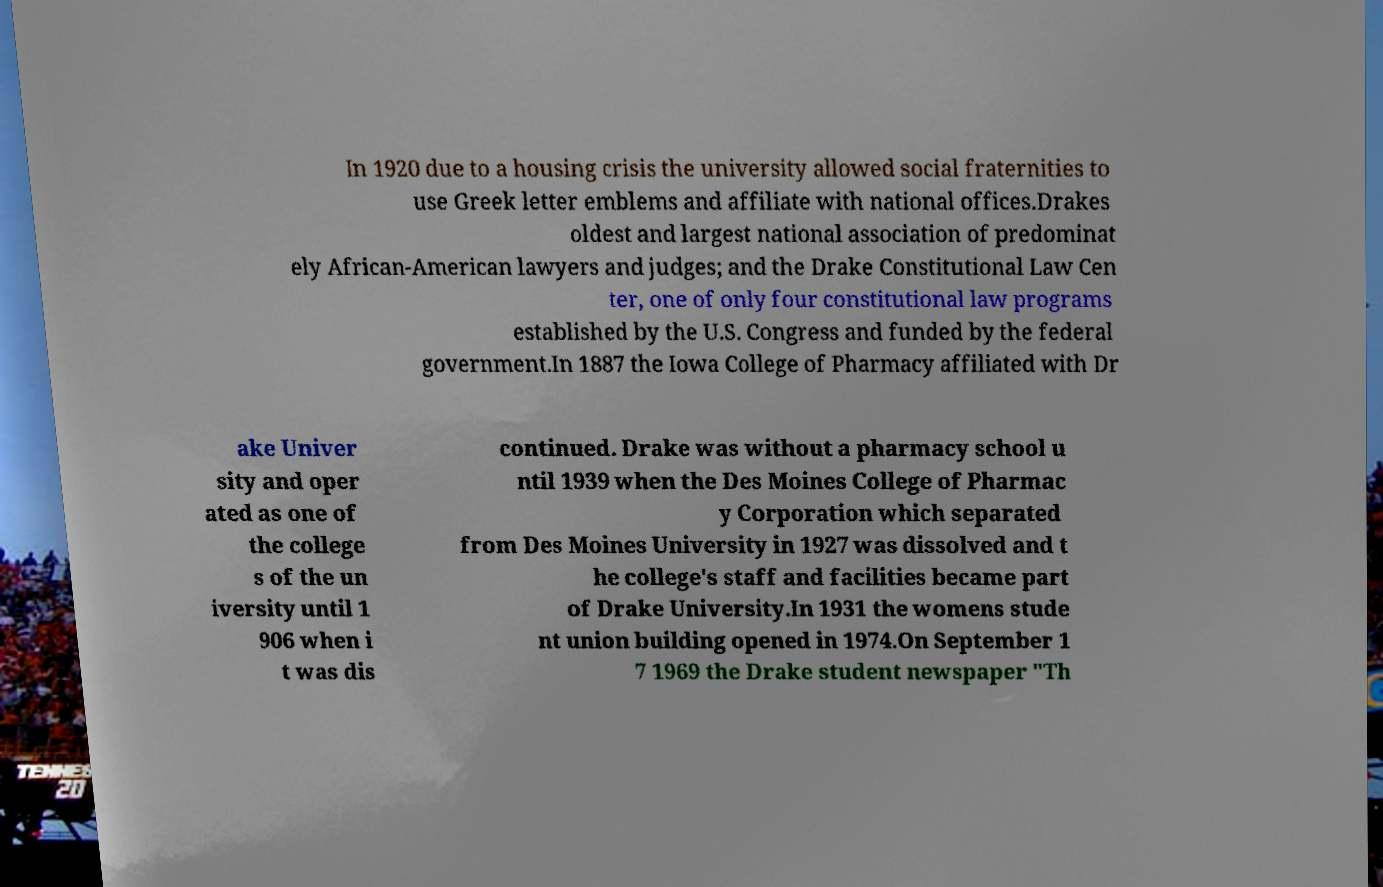I need the written content from this picture converted into text. Can you do that? In 1920 due to a housing crisis the university allowed social fraternities to use Greek letter emblems and affiliate with national offices.Drakes oldest and largest national association of predominat ely African-American lawyers and judges; and the Drake Constitutional Law Cen ter, one of only four constitutional law programs established by the U.S. Congress and funded by the federal government.In 1887 the Iowa College of Pharmacy affiliated with Dr ake Univer sity and oper ated as one of the college s of the un iversity until 1 906 when i t was dis continued. Drake was without a pharmacy school u ntil 1939 when the Des Moines College of Pharmac y Corporation which separated from Des Moines University in 1927 was dissolved and t he college's staff and facilities became part of Drake University.In 1931 the womens stude nt union building opened in 1974.On September 1 7 1969 the Drake student newspaper "Th 